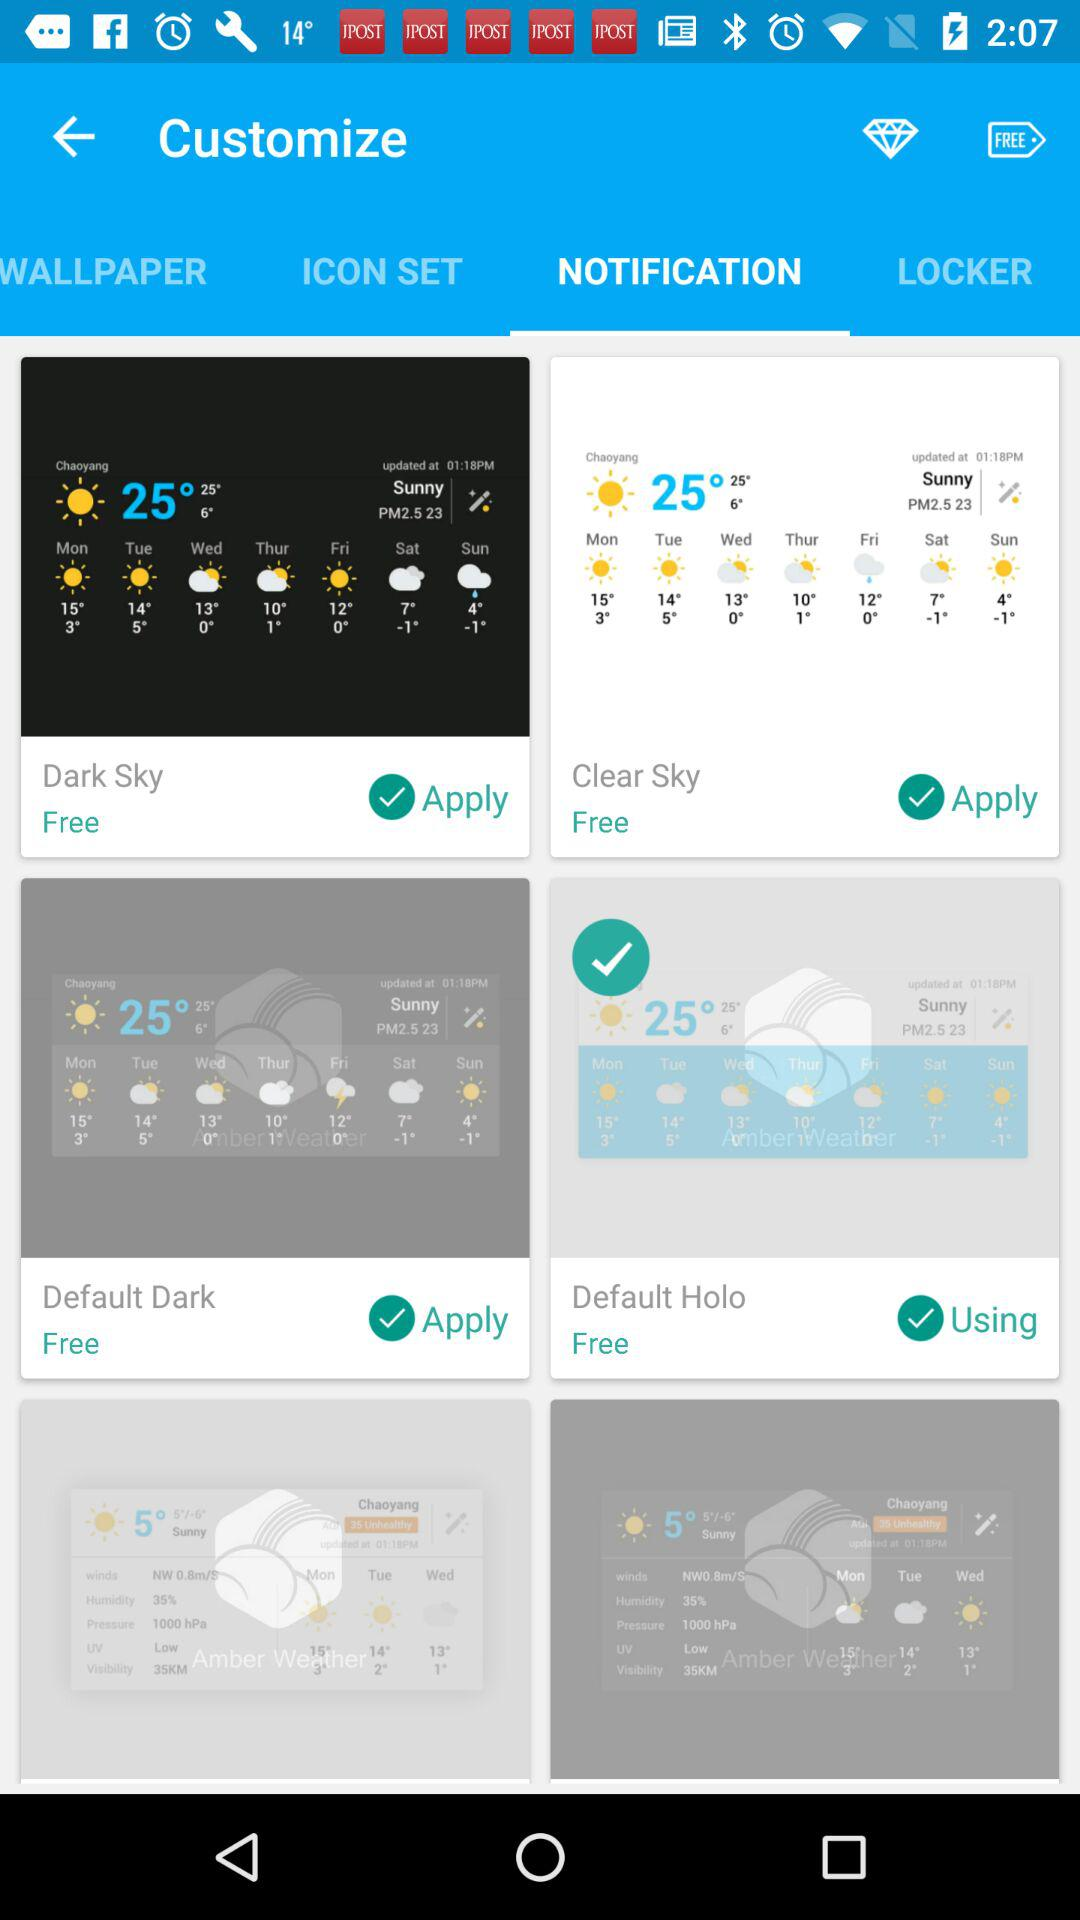Which wallpaper is using?
When the provided information is insufficient, respond with <no answer>. <no answer> 